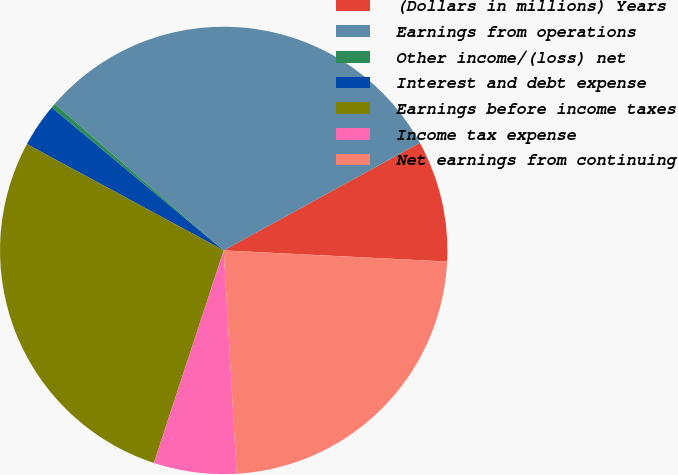Convert chart. <chart><loc_0><loc_0><loc_500><loc_500><pie_chart><fcel>(Dollars in millions) Years<fcel>Earnings from operations<fcel>Other income/(loss) net<fcel>Interest and debt expense<fcel>Earnings before income taxes<fcel>Income tax expense<fcel>Net earnings from continuing<nl><fcel>8.78%<fcel>30.64%<fcel>0.34%<fcel>3.15%<fcel>27.83%<fcel>5.97%<fcel>23.29%<nl></chart> 